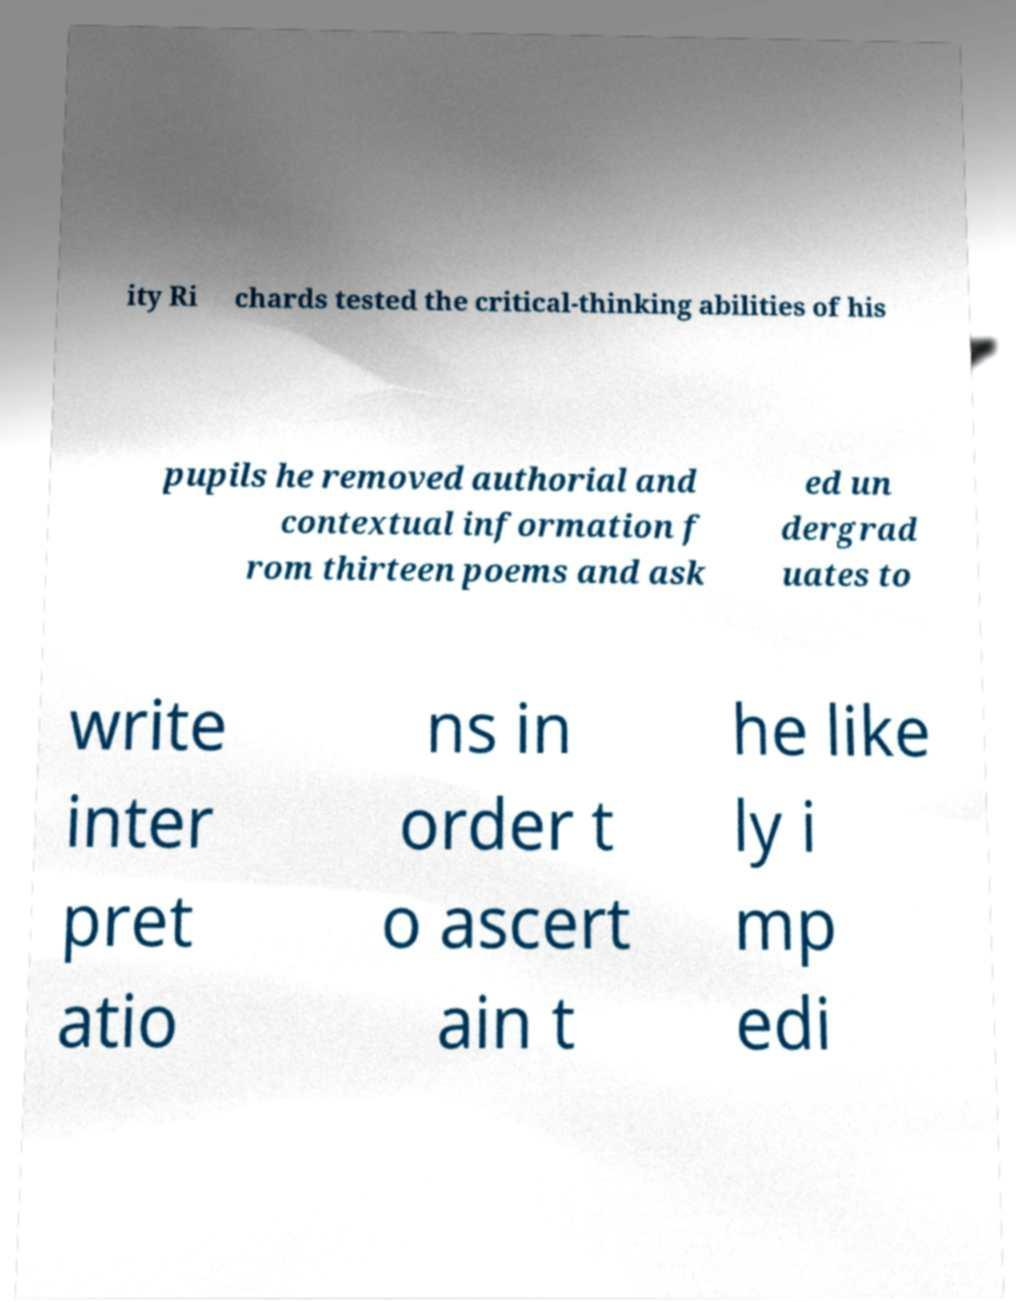For documentation purposes, I need the text within this image transcribed. Could you provide that? ity Ri chards tested the critical-thinking abilities of his pupils he removed authorial and contextual information f rom thirteen poems and ask ed un dergrad uates to write inter pret atio ns in order t o ascert ain t he like ly i mp edi 